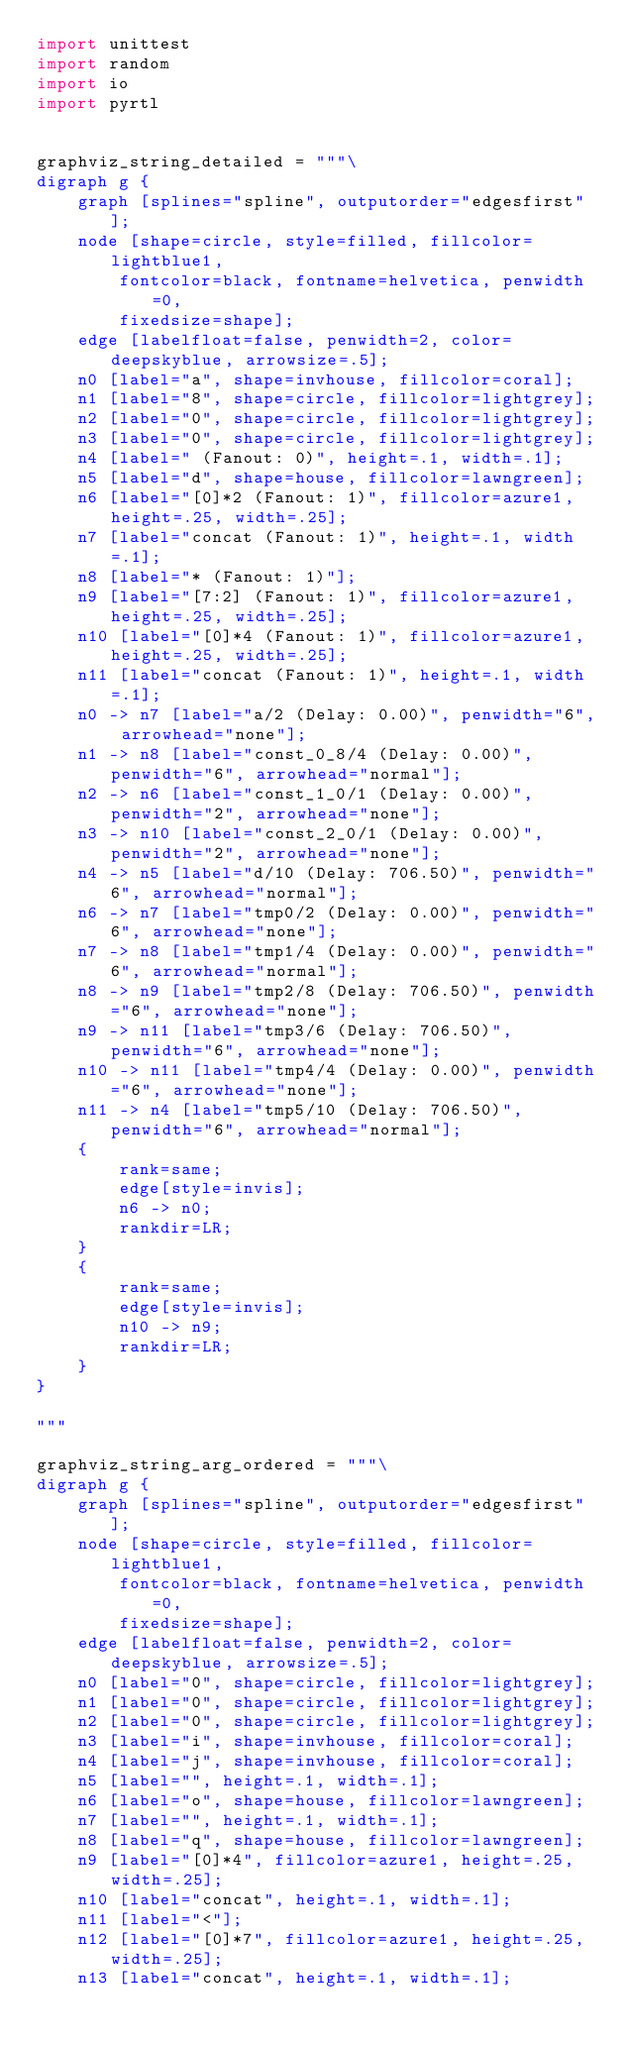Convert code to text. <code><loc_0><loc_0><loc_500><loc_500><_Python_>import unittest
import random
import io
import pyrtl


graphviz_string_detailed = """\
digraph g {
    graph [splines="spline", outputorder="edgesfirst"];
    node [shape=circle, style=filled, fillcolor=lightblue1,
        fontcolor=black, fontname=helvetica, penwidth=0,
        fixedsize=shape];
    edge [labelfloat=false, penwidth=2, color=deepskyblue, arrowsize=.5];
    n0 [label="a", shape=invhouse, fillcolor=coral];
    n1 [label="8", shape=circle, fillcolor=lightgrey];
    n2 [label="0", shape=circle, fillcolor=lightgrey];
    n3 [label="0", shape=circle, fillcolor=lightgrey];
    n4 [label=" (Fanout: 0)", height=.1, width=.1];
    n5 [label="d", shape=house, fillcolor=lawngreen];
    n6 [label="[0]*2 (Fanout: 1)", fillcolor=azure1, height=.25, width=.25];
    n7 [label="concat (Fanout: 1)", height=.1, width=.1];
    n8 [label="* (Fanout: 1)"];
    n9 [label="[7:2] (Fanout: 1)", fillcolor=azure1, height=.25, width=.25];
    n10 [label="[0]*4 (Fanout: 1)", fillcolor=azure1, height=.25, width=.25];
    n11 [label="concat (Fanout: 1)", height=.1, width=.1];
    n0 -> n7 [label="a/2 (Delay: 0.00)", penwidth="6", arrowhead="none"];
    n1 -> n8 [label="const_0_8/4 (Delay: 0.00)", penwidth="6", arrowhead="normal"];
    n2 -> n6 [label="const_1_0/1 (Delay: 0.00)", penwidth="2", arrowhead="none"];
    n3 -> n10 [label="const_2_0/1 (Delay: 0.00)", penwidth="2", arrowhead="none"];
    n4 -> n5 [label="d/10 (Delay: 706.50)", penwidth="6", arrowhead="normal"];
    n6 -> n7 [label="tmp0/2 (Delay: 0.00)", penwidth="6", arrowhead="none"];
    n7 -> n8 [label="tmp1/4 (Delay: 0.00)", penwidth="6", arrowhead="normal"];
    n8 -> n9 [label="tmp2/8 (Delay: 706.50)", penwidth="6", arrowhead="none"];
    n9 -> n11 [label="tmp3/6 (Delay: 706.50)", penwidth="6", arrowhead="none"];
    n10 -> n11 [label="tmp4/4 (Delay: 0.00)", penwidth="6", arrowhead="none"];
    n11 -> n4 [label="tmp5/10 (Delay: 706.50)", penwidth="6", arrowhead="normal"];
    {
        rank=same;
        edge[style=invis];
        n6 -> n0;
        rankdir=LR;
    }
    {
        rank=same;
        edge[style=invis];
        n10 -> n9;
        rankdir=LR;
    }
}

"""

graphviz_string_arg_ordered = """\
digraph g {
    graph [splines="spline", outputorder="edgesfirst"];
    node [shape=circle, style=filled, fillcolor=lightblue1,
        fontcolor=black, fontname=helvetica, penwidth=0,
        fixedsize=shape];
    edge [labelfloat=false, penwidth=2, color=deepskyblue, arrowsize=.5];
    n0 [label="0", shape=circle, fillcolor=lightgrey];
    n1 [label="0", shape=circle, fillcolor=lightgrey];
    n2 [label="0", shape=circle, fillcolor=lightgrey];
    n3 [label="i", shape=invhouse, fillcolor=coral];
    n4 [label="j", shape=invhouse, fillcolor=coral];
    n5 [label="", height=.1, width=.1];
    n6 [label="o", shape=house, fillcolor=lawngreen];
    n7 [label="", height=.1, width=.1];
    n8 [label="q", shape=house, fillcolor=lawngreen];
    n9 [label="[0]*4", fillcolor=azure1, height=.25, width=.25];
    n10 [label="concat", height=.1, width=.1];
    n11 [label="<"];
    n12 [label="[0]*7", fillcolor=azure1, height=.25, width=.25];
    n13 [label="concat", height=.1, width=.1];</code> 